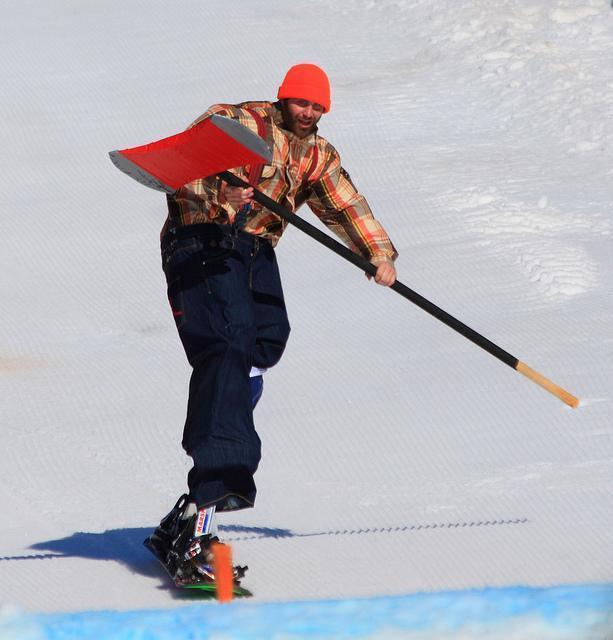How many books are there to the right of the clock?
Give a very brief answer. 0. 